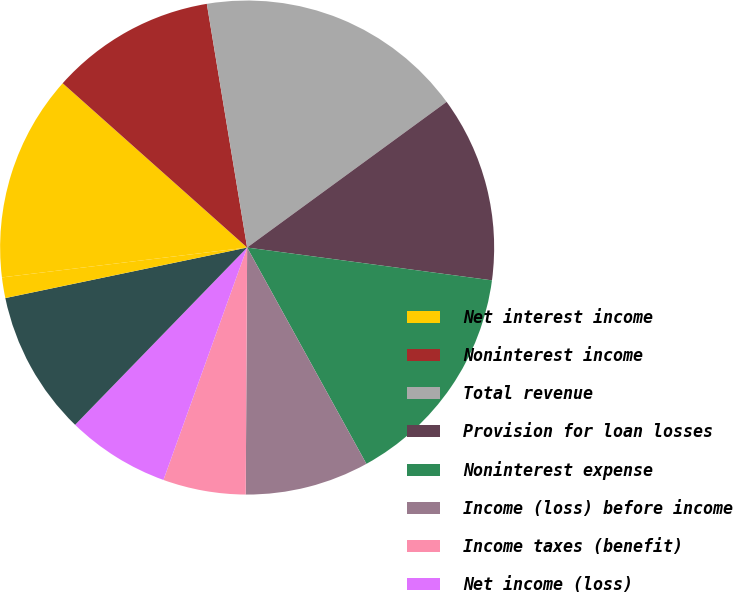Convert chart. <chart><loc_0><loc_0><loc_500><loc_500><pie_chart><fcel>Net interest income<fcel>Noninterest income<fcel>Total revenue<fcel>Provision for loan losses<fcel>Noninterest expense<fcel>Income (loss) before income<fcel>Income taxes (benefit)<fcel>Net income (loss)<fcel>Net earnings (loss) applicable<fcel>Net earnings (loss) - diluted<nl><fcel>13.51%<fcel>10.81%<fcel>17.57%<fcel>12.16%<fcel>14.86%<fcel>8.11%<fcel>5.41%<fcel>6.76%<fcel>9.46%<fcel>1.35%<nl></chart> 